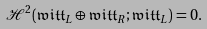Convert formula to latex. <formula><loc_0><loc_0><loc_500><loc_500>\mathcal { H } ^ { 2 } ( \mathfrak { w i t t } _ { L } \oplus \mathfrak { w i t t } _ { R } ; \mathfrak { w i t t } _ { L } ) = 0 .</formula> 